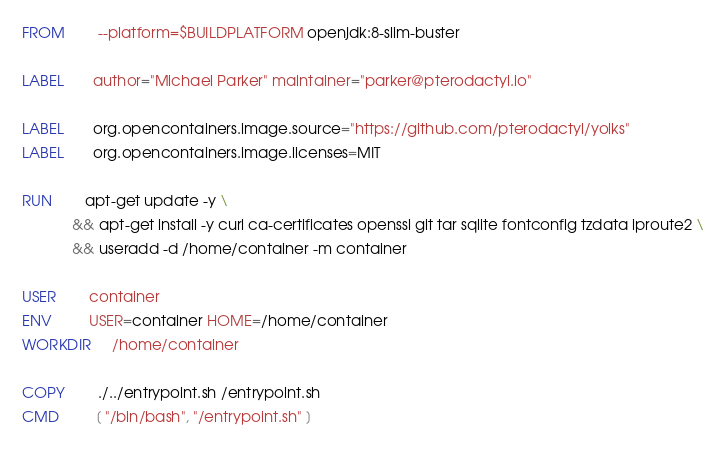<code> <loc_0><loc_0><loc_500><loc_500><_Dockerfile_>FROM        --platform=$BUILDPLATFORM openjdk:8-slim-buster

LABEL       author="Michael Parker" maintainer="parker@pterodactyl.io"

LABEL       org.opencontainers.image.source="https://github.com/pterodactyl/yolks"
LABEL       org.opencontainers.image.licenses=MIT

RUN 		apt-get update -y \
 			&& apt-get install -y curl ca-certificates openssl git tar sqlite fontconfig tzdata iproute2 \
 			&& useradd -d /home/container -m container

USER        container
ENV         USER=container HOME=/home/container
WORKDIR     /home/container

COPY        ./../entrypoint.sh /entrypoint.sh
CMD         [ "/bin/bash", "/entrypoint.sh" ]
</code> 